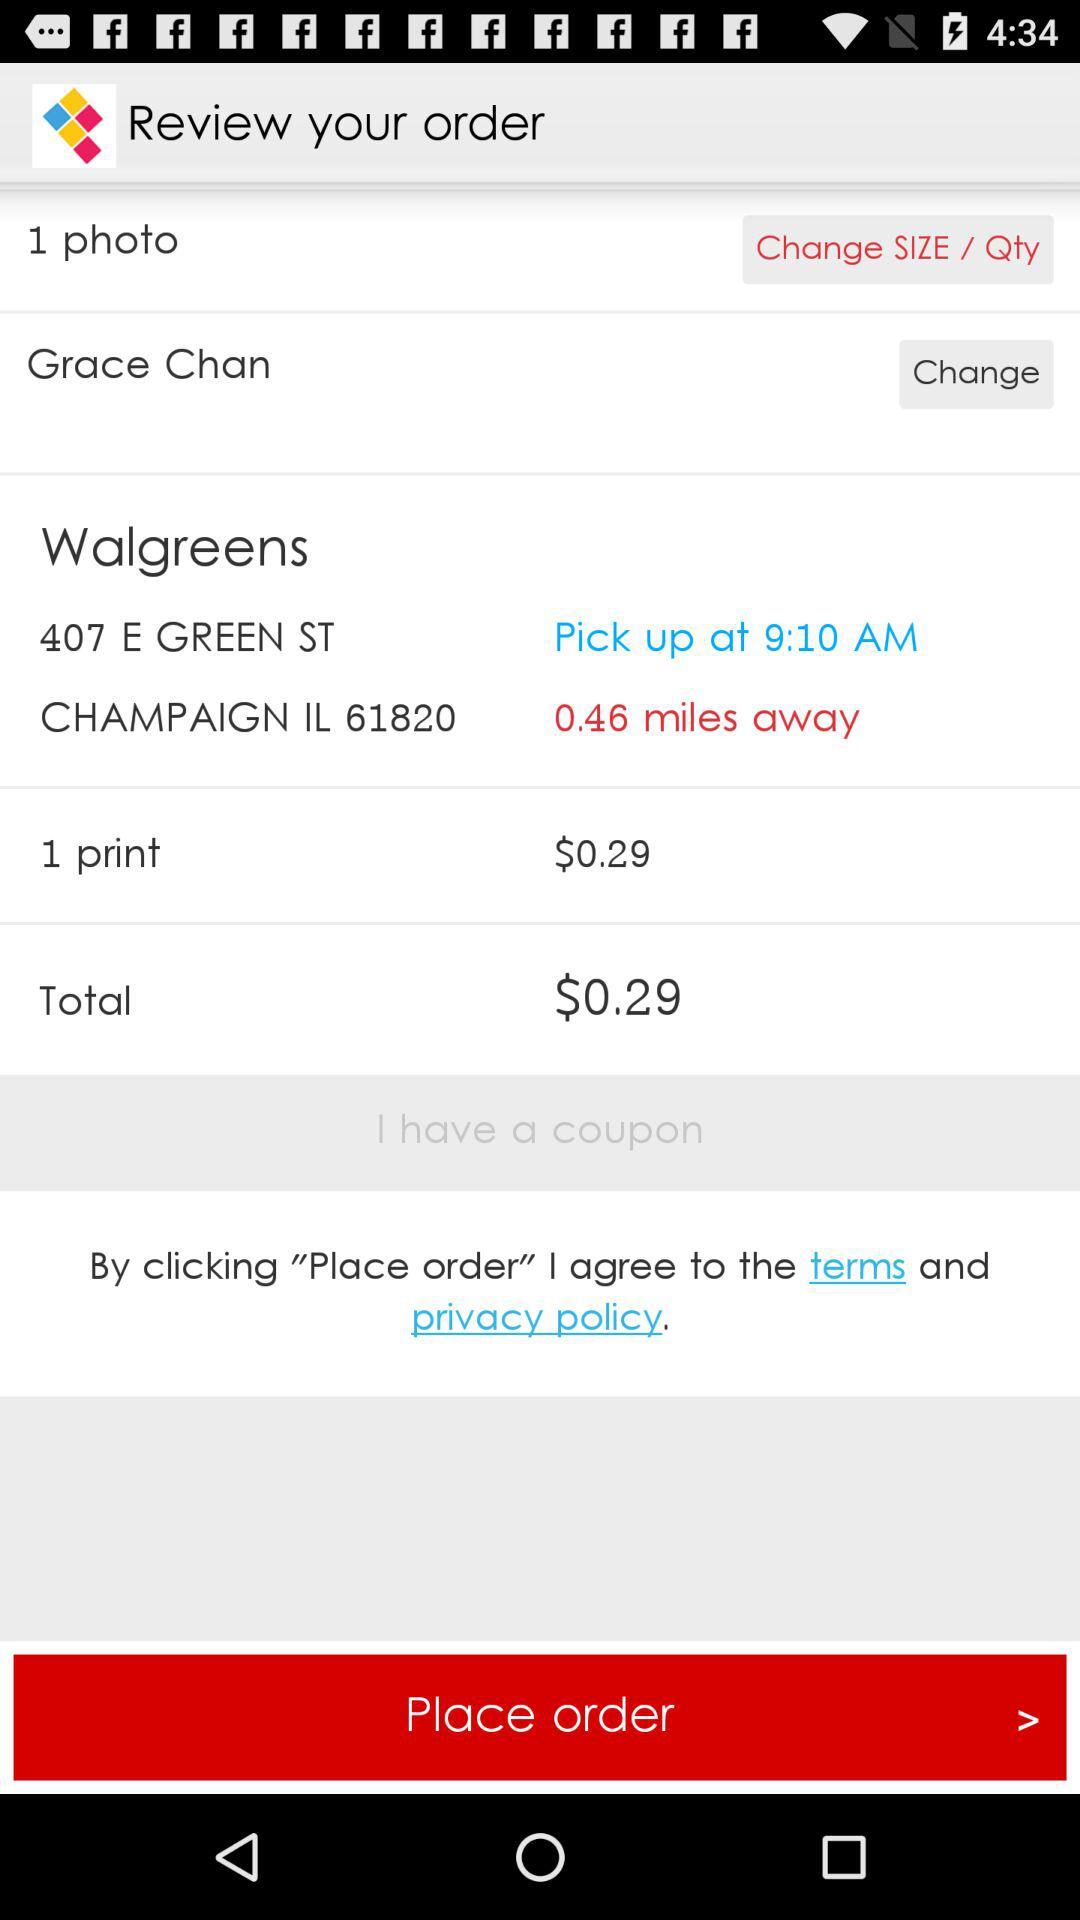How far away is "Walgreens"? The Walgreens is 0.46 miles away. 